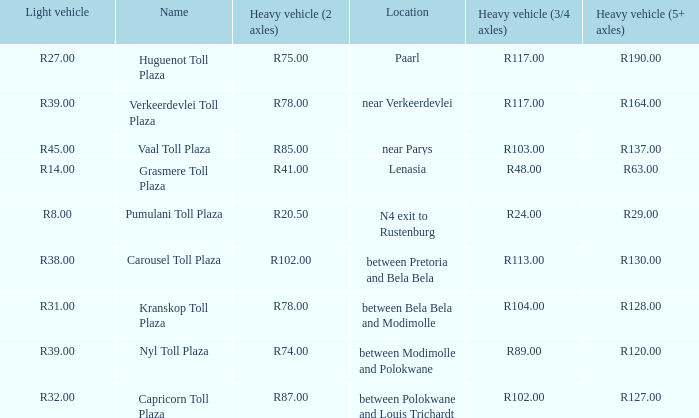What is the toll for light vehicles at the plaza where the toll for heavy vehicles with 2 axles is r87.00? R32.00. 